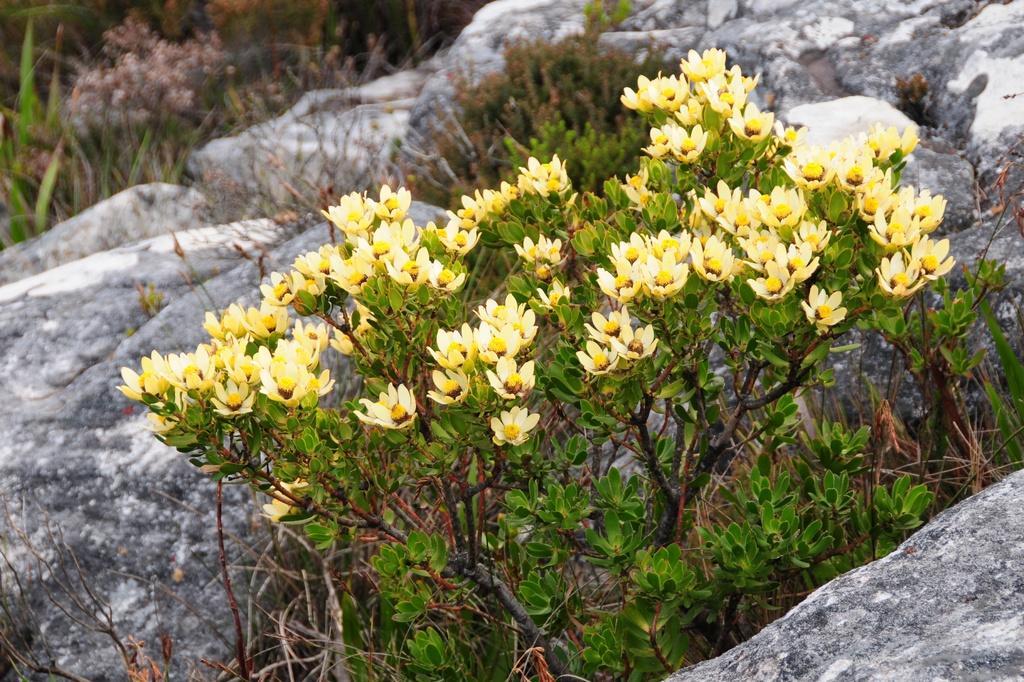In one or two sentences, can you explain what this image depicts? In this image I can see few flowers in yellow color, plants in green color. Background I can see few rocks. 